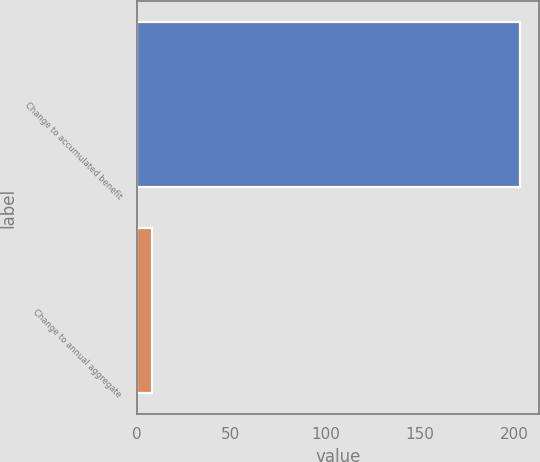<chart> <loc_0><loc_0><loc_500><loc_500><bar_chart><fcel>Change to accumulated benefit<fcel>Change to annual aggregate<nl><fcel>203<fcel>8<nl></chart> 